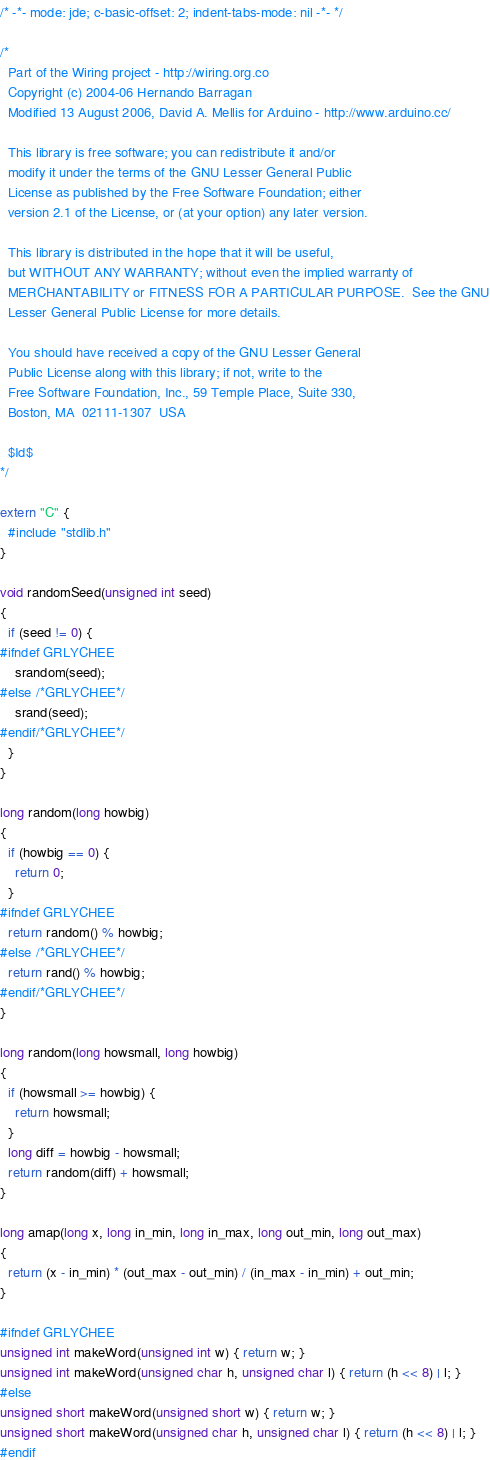<code> <loc_0><loc_0><loc_500><loc_500><_C++_>/* -*- mode: jde; c-basic-offset: 2; indent-tabs-mode: nil -*- */

/*
  Part of the Wiring project - http://wiring.org.co
  Copyright (c) 2004-06 Hernando Barragan
  Modified 13 August 2006, David A. Mellis for Arduino - http://www.arduino.cc/
  
  This library is free software; you can redistribute it and/or
  modify it under the terms of the GNU Lesser General Public
  License as published by the Free Software Foundation; either
  version 2.1 of the License, or (at your option) any later version.

  This library is distributed in the hope that it will be useful,
  but WITHOUT ANY WARRANTY; without even the implied warranty of
  MERCHANTABILITY or FITNESS FOR A PARTICULAR PURPOSE.  See the GNU
  Lesser General Public License for more details.

  You should have received a copy of the GNU Lesser General
  Public License along with this library; if not, write to the
  Free Software Foundation, Inc., 59 Temple Place, Suite 330,
  Boston, MA  02111-1307  USA
  
  $Id$
*/

extern "C" {
  #include "stdlib.h"
}

void randomSeed(unsigned int seed)
{
  if (seed != 0) {
#ifndef GRLYCHEE
    srandom(seed);
#else /*GRLYCHEE*/
    srand(seed);
#endif/*GRLYCHEE*/
  }
}

long random(long howbig)
{
  if (howbig == 0) {
    return 0;
  }
#ifndef GRLYCHEE
  return random() % howbig;
#else /*GRLYCHEE*/
  return rand() % howbig;
#endif/*GRLYCHEE*/
}

long random(long howsmall, long howbig)
{
  if (howsmall >= howbig) {
    return howsmall;
  }
  long diff = howbig - howsmall;
  return random(diff) + howsmall;
}

long amap(long x, long in_min, long in_max, long out_min, long out_max)
{
  return (x - in_min) * (out_max - out_min) / (in_max - in_min) + out_min;
}

#ifndef GRLYCHEE
unsigned int makeWord(unsigned int w) { return w; }
unsigned int makeWord(unsigned char h, unsigned char l) { return (h << 8) | l; }
#else
unsigned short makeWord(unsigned short w) { return w; }
unsigned short makeWord(unsigned char h, unsigned char l) { return (h << 8) | l; }
#endif
</code> 